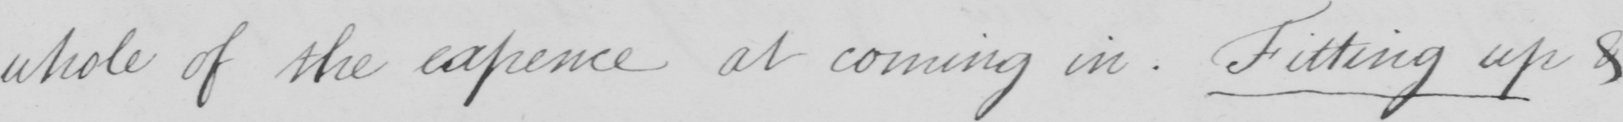Can you tell me what this handwritten text says? whole of the expence at coming in . Fitting up & 